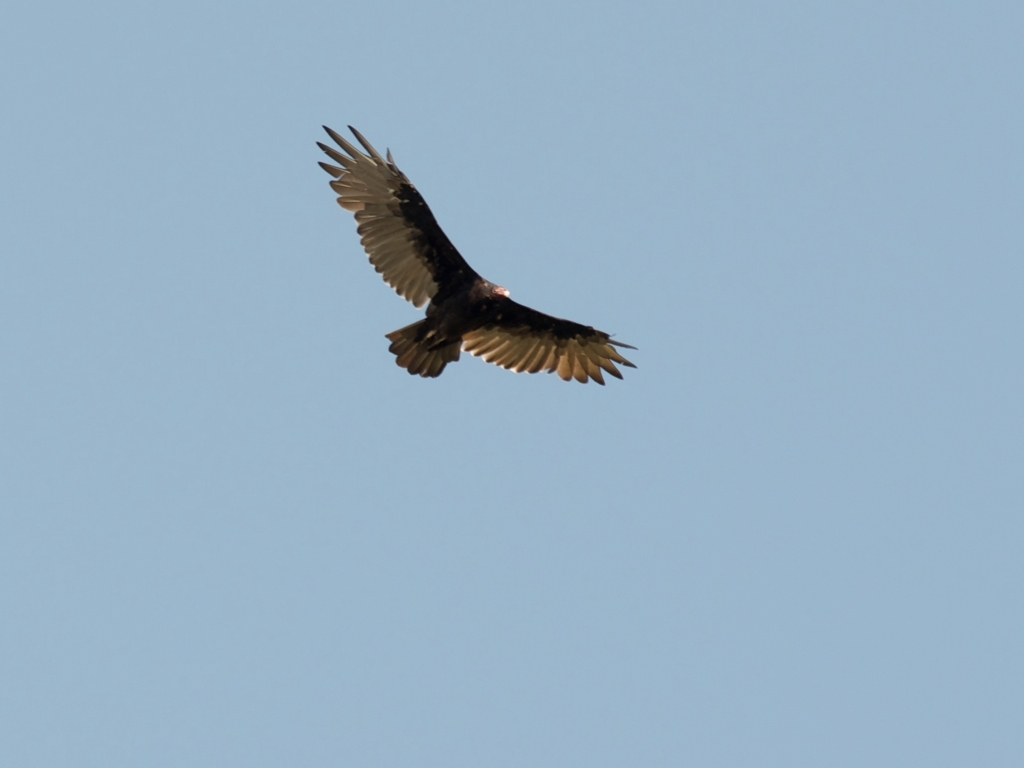What can you say about the details and textures of the main subject?
A. Clear
B. Fuzzy
C. Unclear
D. Lacking in texture
Answer with the option's letter from the given choices directly.
 A. 